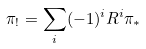Convert formula to latex. <formula><loc_0><loc_0><loc_500><loc_500>\pi _ { ! } = \sum _ { i } ( - 1 ) ^ { i } R ^ { i } \pi _ { * }</formula> 